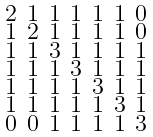Convert formula to latex. <formula><loc_0><loc_0><loc_500><loc_500>\begin{smallmatrix} 2 & 1 & 1 & 1 & 1 & 1 & 0 \\ 1 & 2 & 1 & 1 & 1 & 1 & 0 \\ 1 & 1 & 3 & 1 & 1 & 1 & 1 \\ 1 & 1 & 1 & 3 & 1 & 1 & 1 \\ 1 & 1 & 1 & 1 & 3 & 1 & 1 \\ 1 & 1 & 1 & 1 & 1 & 3 & 1 \\ 0 & 0 & 1 & 1 & 1 & 1 & 3 \end{smallmatrix}</formula> 